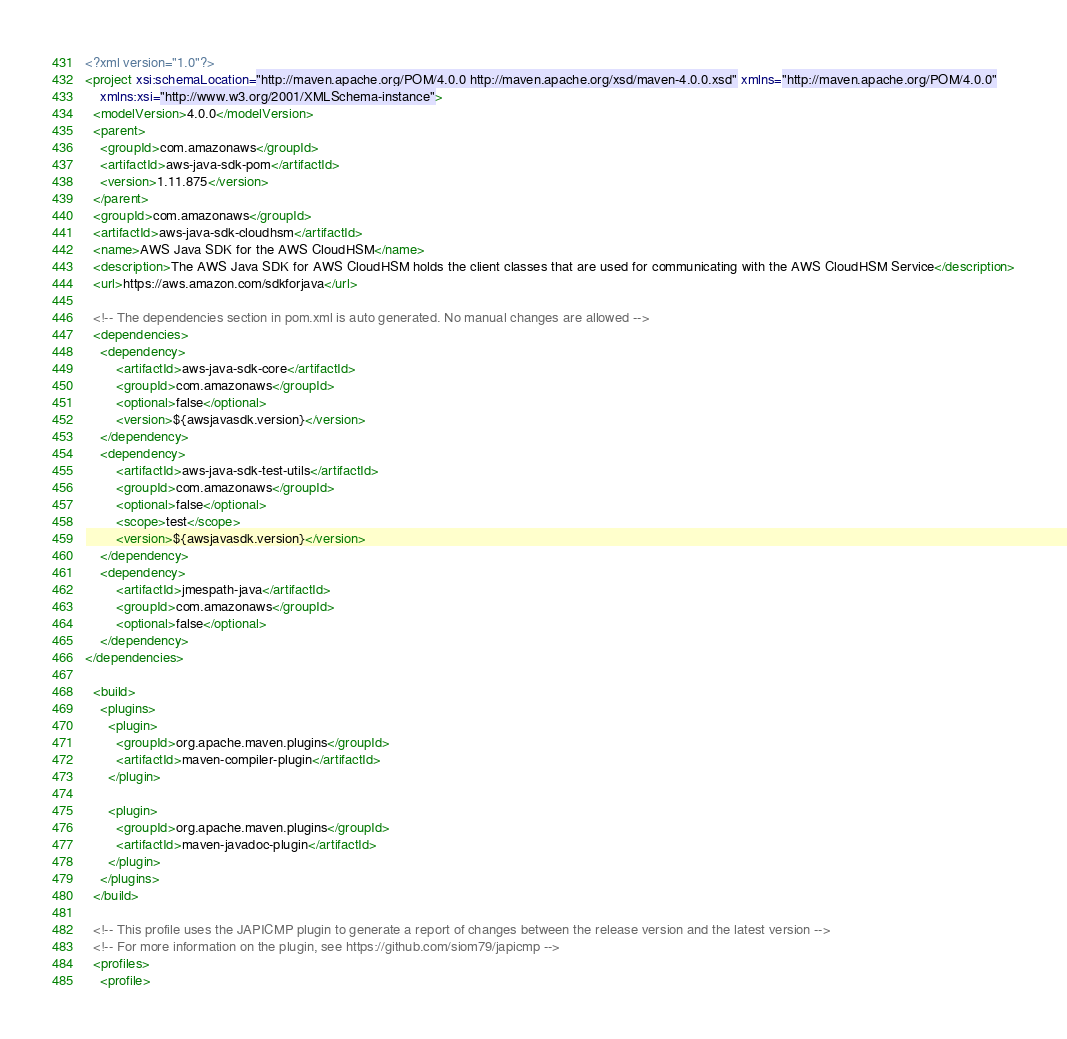Convert code to text. <code><loc_0><loc_0><loc_500><loc_500><_XML_><?xml version="1.0"?>
<project xsi:schemaLocation="http://maven.apache.org/POM/4.0.0 http://maven.apache.org/xsd/maven-4.0.0.xsd" xmlns="http://maven.apache.org/POM/4.0.0"
    xmlns:xsi="http://www.w3.org/2001/XMLSchema-instance">
  <modelVersion>4.0.0</modelVersion>
  <parent>
    <groupId>com.amazonaws</groupId>
    <artifactId>aws-java-sdk-pom</artifactId>
    <version>1.11.875</version>
  </parent>
  <groupId>com.amazonaws</groupId>
  <artifactId>aws-java-sdk-cloudhsm</artifactId>
  <name>AWS Java SDK for the AWS CloudHSM</name>
  <description>The AWS Java SDK for AWS CloudHSM holds the client classes that are used for communicating with the AWS CloudHSM Service</description>
  <url>https://aws.amazon.com/sdkforjava</url>

  <!-- The dependencies section in pom.xml is auto generated. No manual changes are allowed -->
  <dependencies>
    <dependency>
        <artifactId>aws-java-sdk-core</artifactId>
        <groupId>com.amazonaws</groupId>
        <optional>false</optional>
        <version>${awsjavasdk.version}</version>
    </dependency>
    <dependency>
        <artifactId>aws-java-sdk-test-utils</artifactId>
        <groupId>com.amazonaws</groupId>
        <optional>false</optional>
        <scope>test</scope>
        <version>${awsjavasdk.version}</version>
    </dependency>
    <dependency>
        <artifactId>jmespath-java</artifactId>
        <groupId>com.amazonaws</groupId>
        <optional>false</optional>
    </dependency>
</dependencies>

  <build>
    <plugins>
      <plugin>
        <groupId>org.apache.maven.plugins</groupId>
        <artifactId>maven-compiler-plugin</artifactId>
      </plugin>

      <plugin>
        <groupId>org.apache.maven.plugins</groupId>
        <artifactId>maven-javadoc-plugin</artifactId>
      </plugin>
    </plugins>
  </build>

  <!-- This profile uses the JAPICMP plugin to generate a report of changes between the release version and the latest version -->
  <!-- For more information on the plugin, see https://github.com/siom79/japicmp -->
  <profiles>
    <profile></code> 